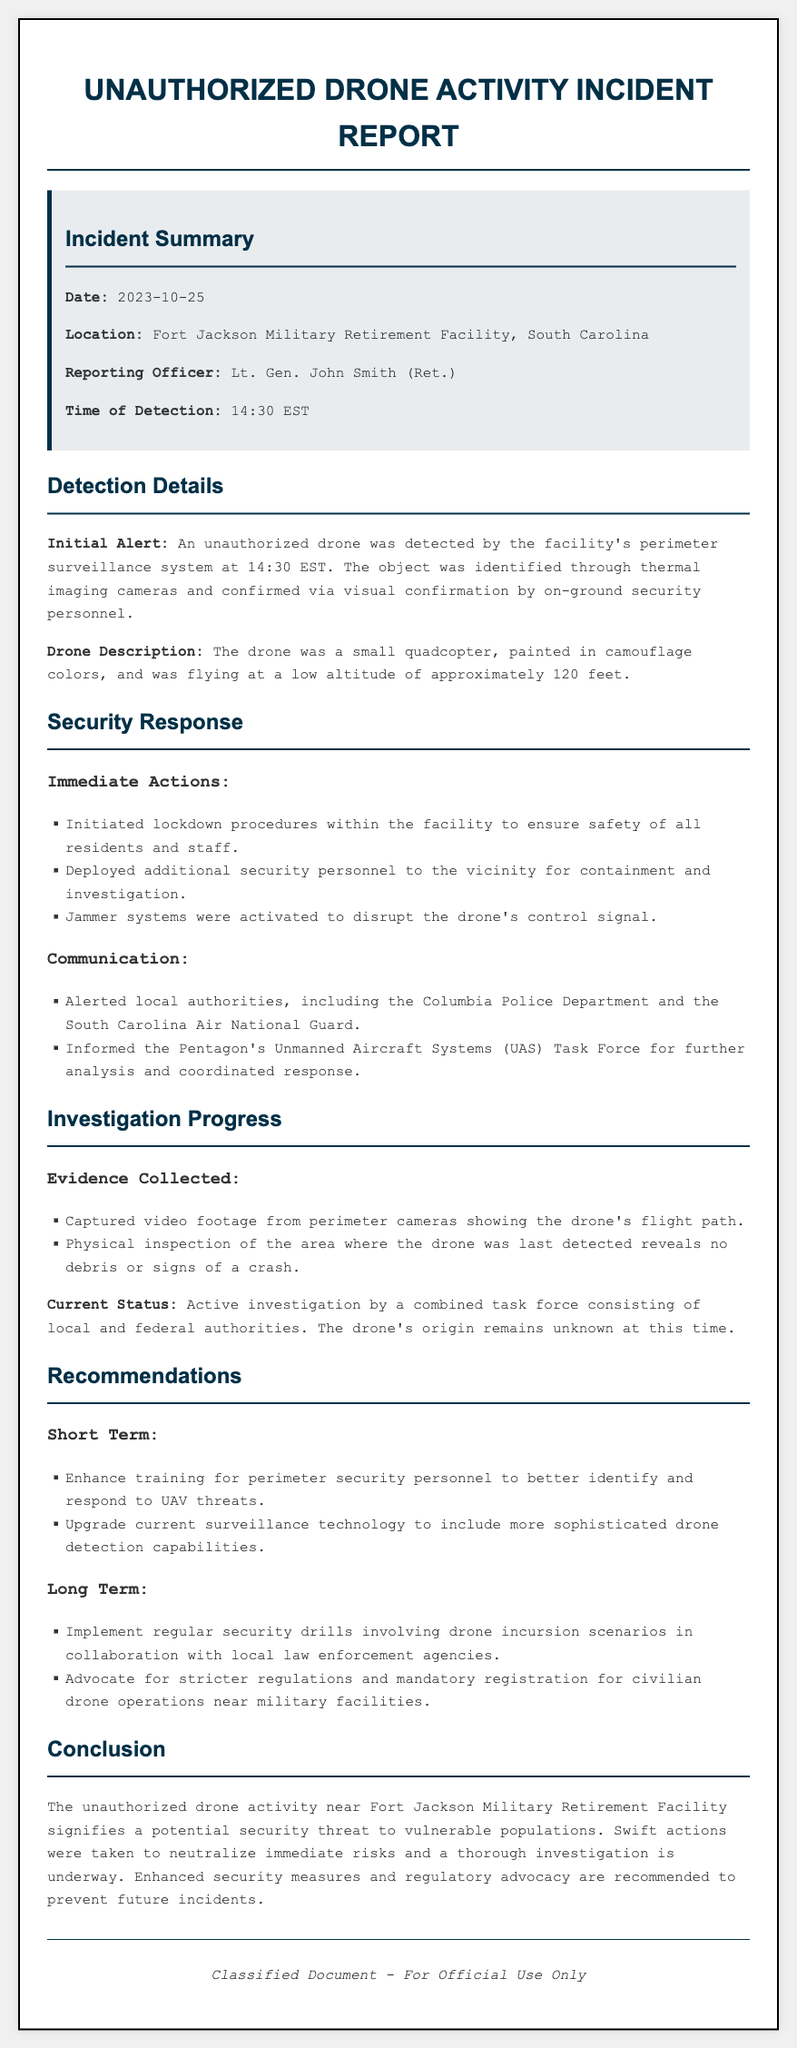What was the date of the incident? The incident report states the date as 2023-10-25.
Answer: 2023-10-25 Where did the unauthorized drone activity occur? The location of the incident is specified as Fort Jackson Military Retirement Facility, South Carolina.
Answer: Fort Jackson Military Retirement Facility, South Carolina Who was the reporting officer for this incident? The document identifies the reporting officer as Lt. Gen. John Smith (Ret.).
Answer: Lt. Gen. John Smith (Ret.) What was the time of detection for the unauthorized drone? The report indicates that the drone was detected at 14:30 EST.
Answer: 14:30 EST What kind of drone was detected? The drone description mentions it was a small quadcopter painted in camouflage colors.
Answer: small quadcopter, painted in camouflage colors What immediate action was taken in response to the detection? One of the immediate actions detailed in the report was to initiate lockdown procedures within the facility.
Answer: Initiated lockdown procedures within the facility What evidence was collected during the investigation? The report states that captured video footage from perimeter cameras showing the drone's flight path was one piece of evidence collected.
Answer: Captured video footage from perimeter cameras What is the current status of the investigation? The report states that the current status is an active investigation by a combined task force.
Answer: Active investigation by a combined task force What is one short-term recommendation made in the report? The report recommends enhancing training for perimeter security personnel as a short-term recommendation.
Answer: Enhance training for perimeter security personnel 